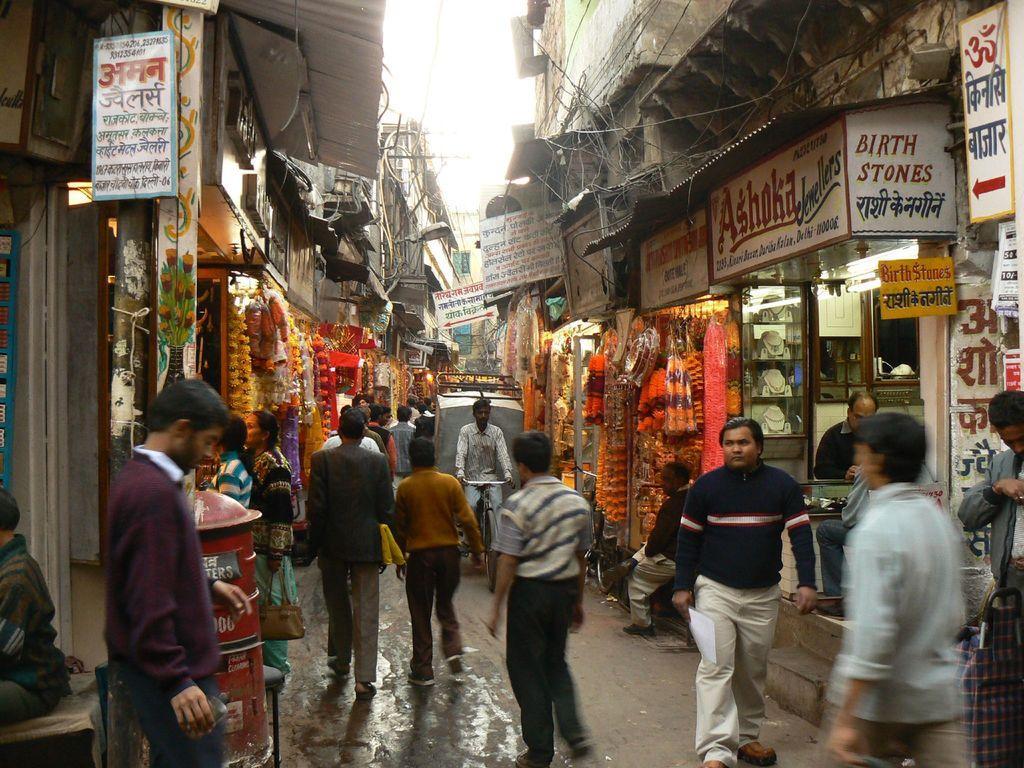Please provide a concise description of this image. In this image I can see the road, few persons standing on the road, a person riding a bicycle, few boards, few wires, few garlands and few buildings on both sides of the road. In the background I can see the sky. 